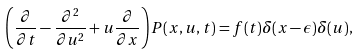Convert formula to latex. <formula><loc_0><loc_0><loc_500><loc_500>\left ( \frac { \partial } { \partial t } - \frac { \partial ^ { 2 } } { \partial u ^ { 2 } } + u \frac { \partial } { \partial x } \right ) P ( x , u , t ) = f ( t ) \delta ( x - \epsilon ) \delta ( u ) ,</formula> 